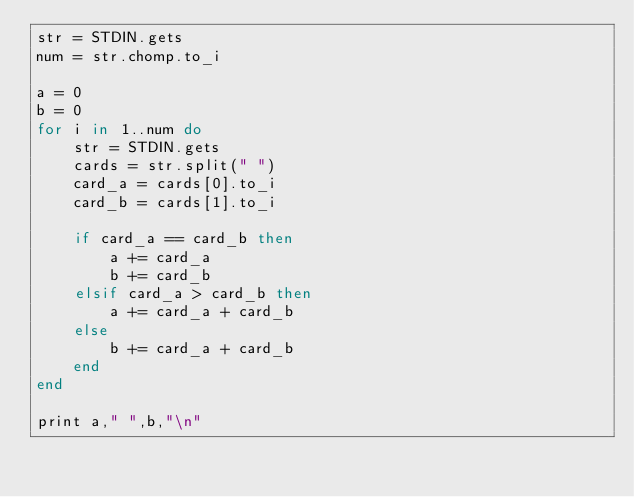Convert code to text. <code><loc_0><loc_0><loc_500><loc_500><_Ruby_>str = STDIN.gets
num = str.chomp.to_i

a = 0
b = 0
for i in 1..num do
	str = STDIN.gets
	cards = str.split(" ")
	card_a = cards[0].to_i
	card_b = cards[1].to_i
	
	if card_a == card_b then
		a += card_a
		b += card_b
	elsif card_a > card_b then
		a += card_a + card_b
	else
		b += card_a + card_b
	end
end

print a," ",b,"\n"</code> 